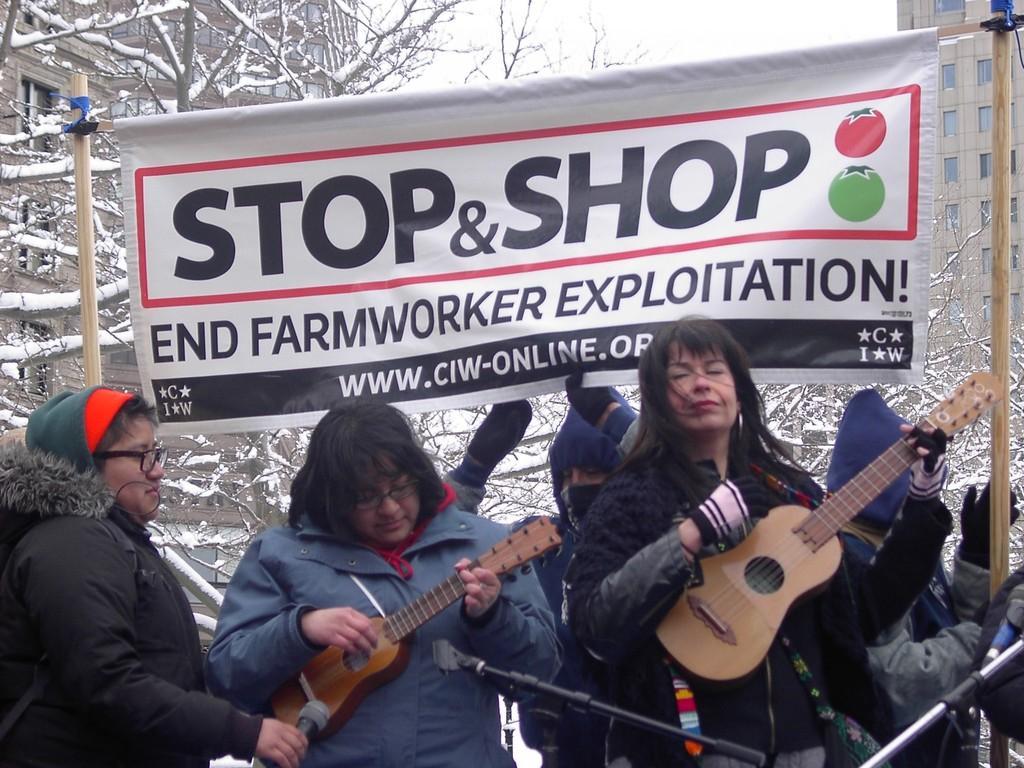Could you give a brief overview of what you see in this image? in the picture we can see three ladies ,two ladies are catching a guitar with a micro phone in front of them. we can also see a banner with the text. 